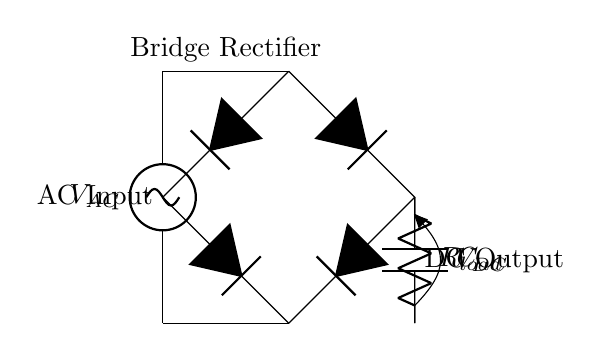What type of rectifier is used in this circuit? The circuit diagram shows a bridge rectifier, which consists of four diodes arranged in a bridge configuration to convert AC to DC.
Answer: bridge rectifier What is the value of the load resistor in the circuit? The circuit diagram labels the load resistor as R load, but no specific value is given for it, thus it remains unspecified in the visual.
Answer: unspecified What component smooths the output voltage? The circuit shows a smoothing capacitor labeled as C, which is used to reduce the ripple in the DC output voltage after rectification.
Answer: C How many diodes are present in the circuit? The bridge rectifier consists of four diodes arranged in a bridge configuration to allow the flow of current in both directions, ensuring full-wave rectification.
Answer: four What is the purpose of the smoothing capacitor in the circuit? The smoothing capacitor is used to store charge and release it to the load, resulting in a more constant DC voltage by reducing fluctuations in the output.
Answer: reduce fluctuations What type of current is converted in this circuit? The circuit diagram shows that it converts AC input voltage, labeled as V AC, into a DC output voltage, labeled as V DC.
Answer: AC What happens to the output voltage when the AC input voltage is applied? When AC voltage is applied, the bridge rectifier conducts current during both halves of the AC cycle, producing a pulsating DC output voltage across the load resistor.
Answer: pulsating DC 